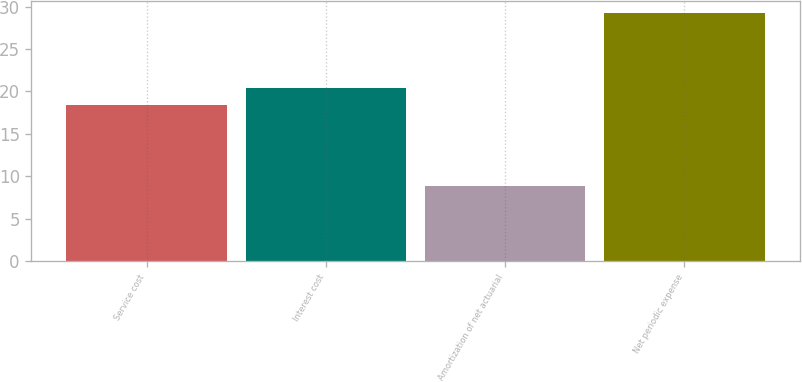Convert chart. <chart><loc_0><loc_0><loc_500><loc_500><bar_chart><fcel>Service cost<fcel>Interest cost<fcel>Amortization of net actuarial<fcel>Net periodic expense<nl><fcel>18.4<fcel>20.44<fcel>8.8<fcel>29.2<nl></chart> 